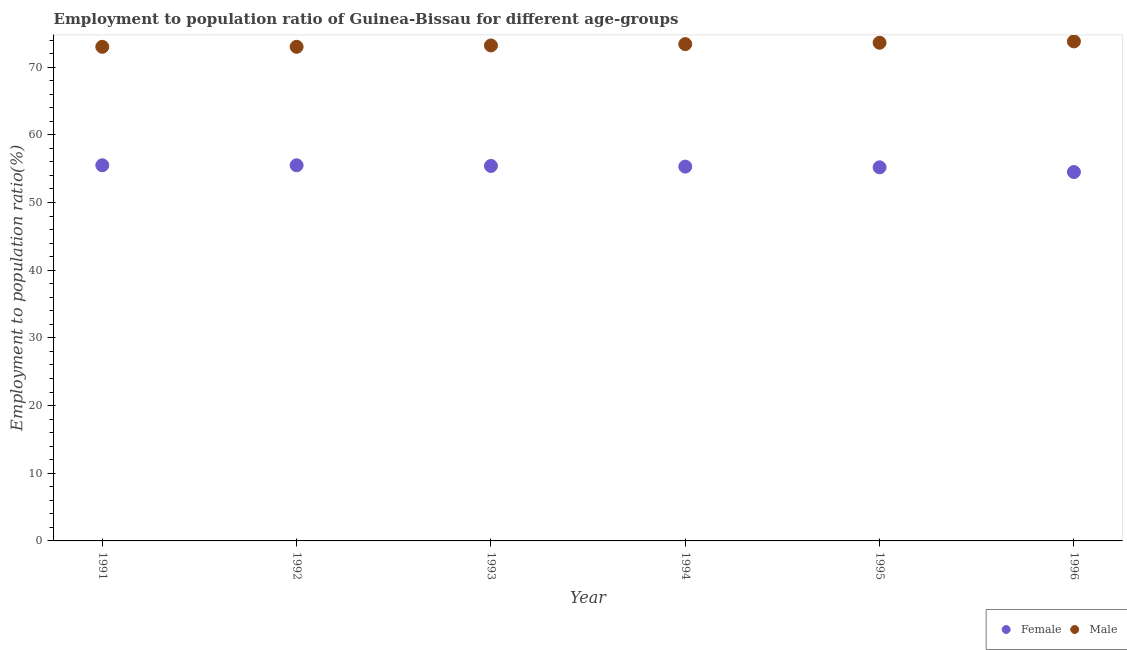How many different coloured dotlines are there?
Your answer should be very brief. 2. What is the employment to population ratio(female) in 1995?
Your answer should be very brief. 55.2. Across all years, what is the maximum employment to population ratio(male)?
Give a very brief answer. 73.8. Across all years, what is the minimum employment to population ratio(female)?
Provide a short and direct response. 54.5. In which year was the employment to population ratio(female) minimum?
Offer a very short reply. 1996. What is the total employment to population ratio(female) in the graph?
Provide a succinct answer. 331.4. What is the difference between the employment to population ratio(female) in 1991 and that in 1994?
Keep it short and to the point. 0.2. What is the difference between the employment to population ratio(male) in 1994 and the employment to population ratio(female) in 1995?
Your answer should be very brief. 18.2. What is the average employment to population ratio(male) per year?
Provide a short and direct response. 73.33. In the year 1995, what is the difference between the employment to population ratio(female) and employment to population ratio(male)?
Keep it short and to the point. -18.4. What is the ratio of the employment to population ratio(male) in 1994 to that in 1996?
Offer a terse response. 0.99. Is the employment to population ratio(male) in 1992 less than that in 1994?
Make the answer very short. Yes. What is the difference between the highest and the second highest employment to population ratio(male)?
Offer a very short reply. 0.2. What is the difference between the highest and the lowest employment to population ratio(female)?
Ensure brevity in your answer.  1. Does the employment to population ratio(male) monotonically increase over the years?
Keep it short and to the point. No. Is the employment to population ratio(male) strictly less than the employment to population ratio(female) over the years?
Offer a very short reply. No. How many dotlines are there?
Provide a short and direct response. 2. How many years are there in the graph?
Ensure brevity in your answer.  6. What is the difference between two consecutive major ticks on the Y-axis?
Offer a terse response. 10. Are the values on the major ticks of Y-axis written in scientific E-notation?
Your answer should be compact. No. Does the graph contain grids?
Give a very brief answer. No. How many legend labels are there?
Provide a short and direct response. 2. What is the title of the graph?
Your answer should be very brief. Employment to population ratio of Guinea-Bissau for different age-groups. Does "Methane" appear as one of the legend labels in the graph?
Provide a short and direct response. No. What is the Employment to population ratio(%) in Female in 1991?
Your answer should be compact. 55.5. What is the Employment to population ratio(%) of Male in 1991?
Provide a succinct answer. 73. What is the Employment to population ratio(%) in Female in 1992?
Offer a very short reply. 55.5. What is the Employment to population ratio(%) of Female in 1993?
Offer a very short reply. 55.4. What is the Employment to population ratio(%) of Male in 1993?
Offer a terse response. 73.2. What is the Employment to population ratio(%) in Female in 1994?
Ensure brevity in your answer.  55.3. What is the Employment to population ratio(%) in Male in 1994?
Offer a very short reply. 73.4. What is the Employment to population ratio(%) in Female in 1995?
Offer a terse response. 55.2. What is the Employment to population ratio(%) in Male in 1995?
Your response must be concise. 73.6. What is the Employment to population ratio(%) in Female in 1996?
Ensure brevity in your answer.  54.5. What is the Employment to population ratio(%) in Male in 1996?
Give a very brief answer. 73.8. Across all years, what is the maximum Employment to population ratio(%) of Female?
Provide a succinct answer. 55.5. Across all years, what is the maximum Employment to population ratio(%) of Male?
Give a very brief answer. 73.8. Across all years, what is the minimum Employment to population ratio(%) in Female?
Your response must be concise. 54.5. What is the total Employment to population ratio(%) in Female in the graph?
Make the answer very short. 331.4. What is the total Employment to population ratio(%) in Male in the graph?
Keep it short and to the point. 440. What is the difference between the Employment to population ratio(%) of Female in 1991 and that in 1993?
Provide a short and direct response. 0.1. What is the difference between the Employment to population ratio(%) in Male in 1991 and that in 1993?
Your answer should be very brief. -0.2. What is the difference between the Employment to population ratio(%) in Female in 1991 and that in 1994?
Ensure brevity in your answer.  0.2. What is the difference between the Employment to population ratio(%) of Male in 1991 and that in 1994?
Keep it short and to the point. -0.4. What is the difference between the Employment to population ratio(%) of Female in 1991 and that in 1995?
Provide a succinct answer. 0.3. What is the difference between the Employment to population ratio(%) of Male in 1991 and that in 1995?
Your answer should be very brief. -0.6. What is the difference between the Employment to population ratio(%) of Female in 1991 and that in 1996?
Ensure brevity in your answer.  1. What is the difference between the Employment to population ratio(%) in Male in 1991 and that in 1996?
Give a very brief answer. -0.8. What is the difference between the Employment to population ratio(%) in Female in 1992 and that in 1993?
Your response must be concise. 0.1. What is the difference between the Employment to population ratio(%) of Female in 1992 and that in 1994?
Your answer should be compact. 0.2. What is the difference between the Employment to population ratio(%) in Male in 1992 and that in 1995?
Offer a very short reply. -0.6. What is the difference between the Employment to population ratio(%) in Female in 1993 and that in 1994?
Your answer should be very brief. 0.1. What is the difference between the Employment to population ratio(%) in Male in 1993 and that in 1996?
Provide a short and direct response. -0.6. What is the difference between the Employment to population ratio(%) in Female in 1994 and that in 1995?
Ensure brevity in your answer.  0.1. What is the difference between the Employment to population ratio(%) in Female in 1995 and that in 1996?
Offer a very short reply. 0.7. What is the difference between the Employment to population ratio(%) of Male in 1995 and that in 1996?
Provide a succinct answer. -0.2. What is the difference between the Employment to population ratio(%) of Female in 1991 and the Employment to population ratio(%) of Male in 1992?
Your response must be concise. -17.5. What is the difference between the Employment to population ratio(%) in Female in 1991 and the Employment to population ratio(%) in Male in 1993?
Your answer should be compact. -17.7. What is the difference between the Employment to population ratio(%) in Female in 1991 and the Employment to population ratio(%) in Male in 1994?
Offer a terse response. -17.9. What is the difference between the Employment to population ratio(%) in Female in 1991 and the Employment to population ratio(%) in Male in 1995?
Offer a terse response. -18.1. What is the difference between the Employment to population ratio(%) of Female in 1991 and the Employment to population ratio(%) of Male in 1996?
Make the answer very short. -18.3. What is the difference between the Employment to population ratio(%) in Female in 1992 and the Employment to population ratio(%) in Male in 1993?
Your answer should be compact. -17.7. What is the difference between the Employment to population ratio(%) of Female in 1992 and the Employment to population ratio(%) of Male in 1994?
Your response must be concise. -17.9. What is the difference between the Employment to population ratio(%) in Female in 1992 and the Employment to population ratio(%) in Male in 1995?
Offer a terse response. -18.1. What is the difference between the Employment to population ratio(%) of Female in 1992 and the Employment to population ratio(%) of Male in 1996?
Provide a succinct answer. -18.3. What is the difference between the Employment to population ratio(%) of Female in 1993 and the Employment to population ratio(%) of Male in 1994?
Ensure brevity in your answer.  -18. What is the difference between the Employment to population ratio(%) of Female in 1993 and the Employment to population ratio(%) of Male in 1995?
Make the answer very short. -18.2. What is the difference between the Employment to population ratio(%) in Female in 1993 and the Employment to population ratio(%) in Male in 1996?
Provide a succinct answer. -18.4. What is the difference between the Employment to population ratio(%) in Female in 1994 and the Employment to population ratio(%) in Male in 1995?
Offer a very short reply. -18.3. What is the difference between the Employment to population ratio(%) of Female in 1994 and the Employment to population ratio(%) of Male in 1996?
Your response must be concise. -18.5. What is the difference between the Employment to population ratio(%) of Female in 1995 and the Employment to population ratio(%) of Male in 1996?
Keep it short and to the point. -18.6. What is the average Employment to population ratio(%) of Female per year?
Provide a succinct answer. 55.23. What is the average Employment to population ratio(%) of Male per year?
Offer a very short reply. 73.33. In the year 1991, what is the difference between the Employment to population ratio(%) of Female and Employment to population ratio(%) of Male?
Give a very brief answer. -17.5. In the year 1992, what is the difference between the Employment to population ratio(%) in Female and Employment to population ratio(%) in Male?
Your answer should be very brief. -17.5. In the year 1993, what is the difference between the Employment to population ratio(%) of Female and Employment to population ratio(%) of Male?
Offer a terse response. -17.8. In the year 1994, what is the difference between the Employment to population ratio(%) in Female and Employment to population ratio(%) in Male?
Offer a terse response. -18.1. In the year 1995, what is the difference between the Employment to population ratio(%) in Female and Employment to population ratio(%) in Male?
Keep it short and to the point. -18.4. In the year 1996, what is the difference between the Employment to population ratio(%) of Female and Employment to population ratio(%) of Male?
Provide a succinct answer. -19.3. What is the ratio of the Employment to population ratio(%) in Female in 1991 to that in 1992?
Keep it short and to the point. 1. What is the ratio of the Employment to population ratio(%) of Male in 1991 to that in 1993?
Offer a terse response. 1. What is the ratio of the Employment to population ratio(%) of Female in 1991 to that in 1994?
Provide a succinct answer. 1. What is the ratio of the Employment to population ratio(%) in Female in 1991 to that in 1995?
Your answer should be compact. 1.01. What is the ratio of the Employment to population ratio(%) in Male in 1991 to that in 1995?
Ensure brevity in your answer.  0.99. What is the ratio of the Employment to population ratio(%) of Female in 1991 to that in 1996?
Offer a terse response. 1.02. What is the ratio of the Employment to population ratio(%) in Male in 1991 to that in 1996?
Ensure brevity in your answer.  0.99. What is the ratio of the Employment to population ratio(%) in Female in 1992 to that in 1993?
Give a very brief answer. 1. What is the ratio of the Employment to population ratio(%) in Male in 1992 to that in 1993?
Ensure brevity in your answer.  1. What is the ratio of the Employment to population ratio(%) of Female in 1992 to that in 1994?
Give a very brief answer. 1. What is the ratio of the Employment to population ratio(%) in Female in 1992 to that in 1995?
Provide a succinct answer. 1.01. What is the ratio of the Employment to population ratio(%) of Male in 1992 to that in 1995?
Offer a very short reply. 0.99. What is the ratio of the Employment to population ratio(%) in Female in 1992 to that in 1996?
Provide a short and direct response. 1.02. What is the ratio of the Employment to population ratio(%) of Male in 1992 to that in 1996?
Make the answer very short. 0.99. What is the ratio of the Employment to population ratio(%) in Female in 1993 to that in 1994?
Ensure brevity in your answer.  1. What is the ratio of the Employment to population ratio(%) in Female in 1993 to that in 1995?
Offer a very short reply. 1. What is the ratio of the Employment to population ratio(%) of Male in 1993 to that in 1995?
Your answer should be compact. 0.99. What is the ratio of the Employment to population ratio(%) of Female in 1993 to that in 1996?
Give a very brief answer. 1.02. What is the ratio of the Employment to population ratio(%) of Female in 1994 to that in 1996?
Your answer should be compact. 1.01. What is the ratio of the Employment to population ratio(%) of Male in 1994 to that in 1996?
Keep it short and to the point. 0.99. What is the ratio of the Employment to population ratio(%) in Female in 1995 to that in 1996?
Your answer should be very brief. 1.01. What is the ratio of the Employment to population ratio(%) in Male in 1995 to that in 1996?
Keep it short and to the point. 1. What is the difference between the highest and the second highest Employment to population ratio(%) of Male?
Your answer should be very brief. 0.2. What is the difference between the highest and the lowest Employment to population ratio(%) of Male?
Provide a succinct answer. 0.8. 